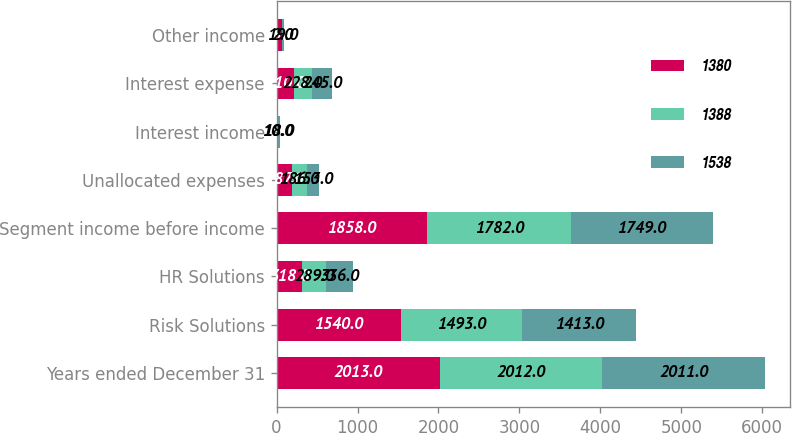Convert chart. <chart><loc_0><loc_0><loc_500><loc_500><stacked_bar_chart><ecel><fcel>Years ended December 31<fcel>Risk Solutions<fcel>HR Solutions<fcel>Segment income before income<fcel>Unallocated expenses<fcel>Interest income<fcel>Interest expense<fcel>Other income<nl><fcel>1380<fcel>2013<fcel>1540<fcel>318<fcel>1858<fcel>187<fcel>9<fcel>210<fcel>68<nl><fcel>1388<fcel>2012<fcel>1493<fcel>289<fcel>1782<fcel>186<fcel>10<fcel>228<fcel>2<nl><fcel>1538<fcel>2011<fcel>1413<fcel>336<fcel>1749<fcel>153<fcel>18<fcel>245<fcel>19<nl></chart> 